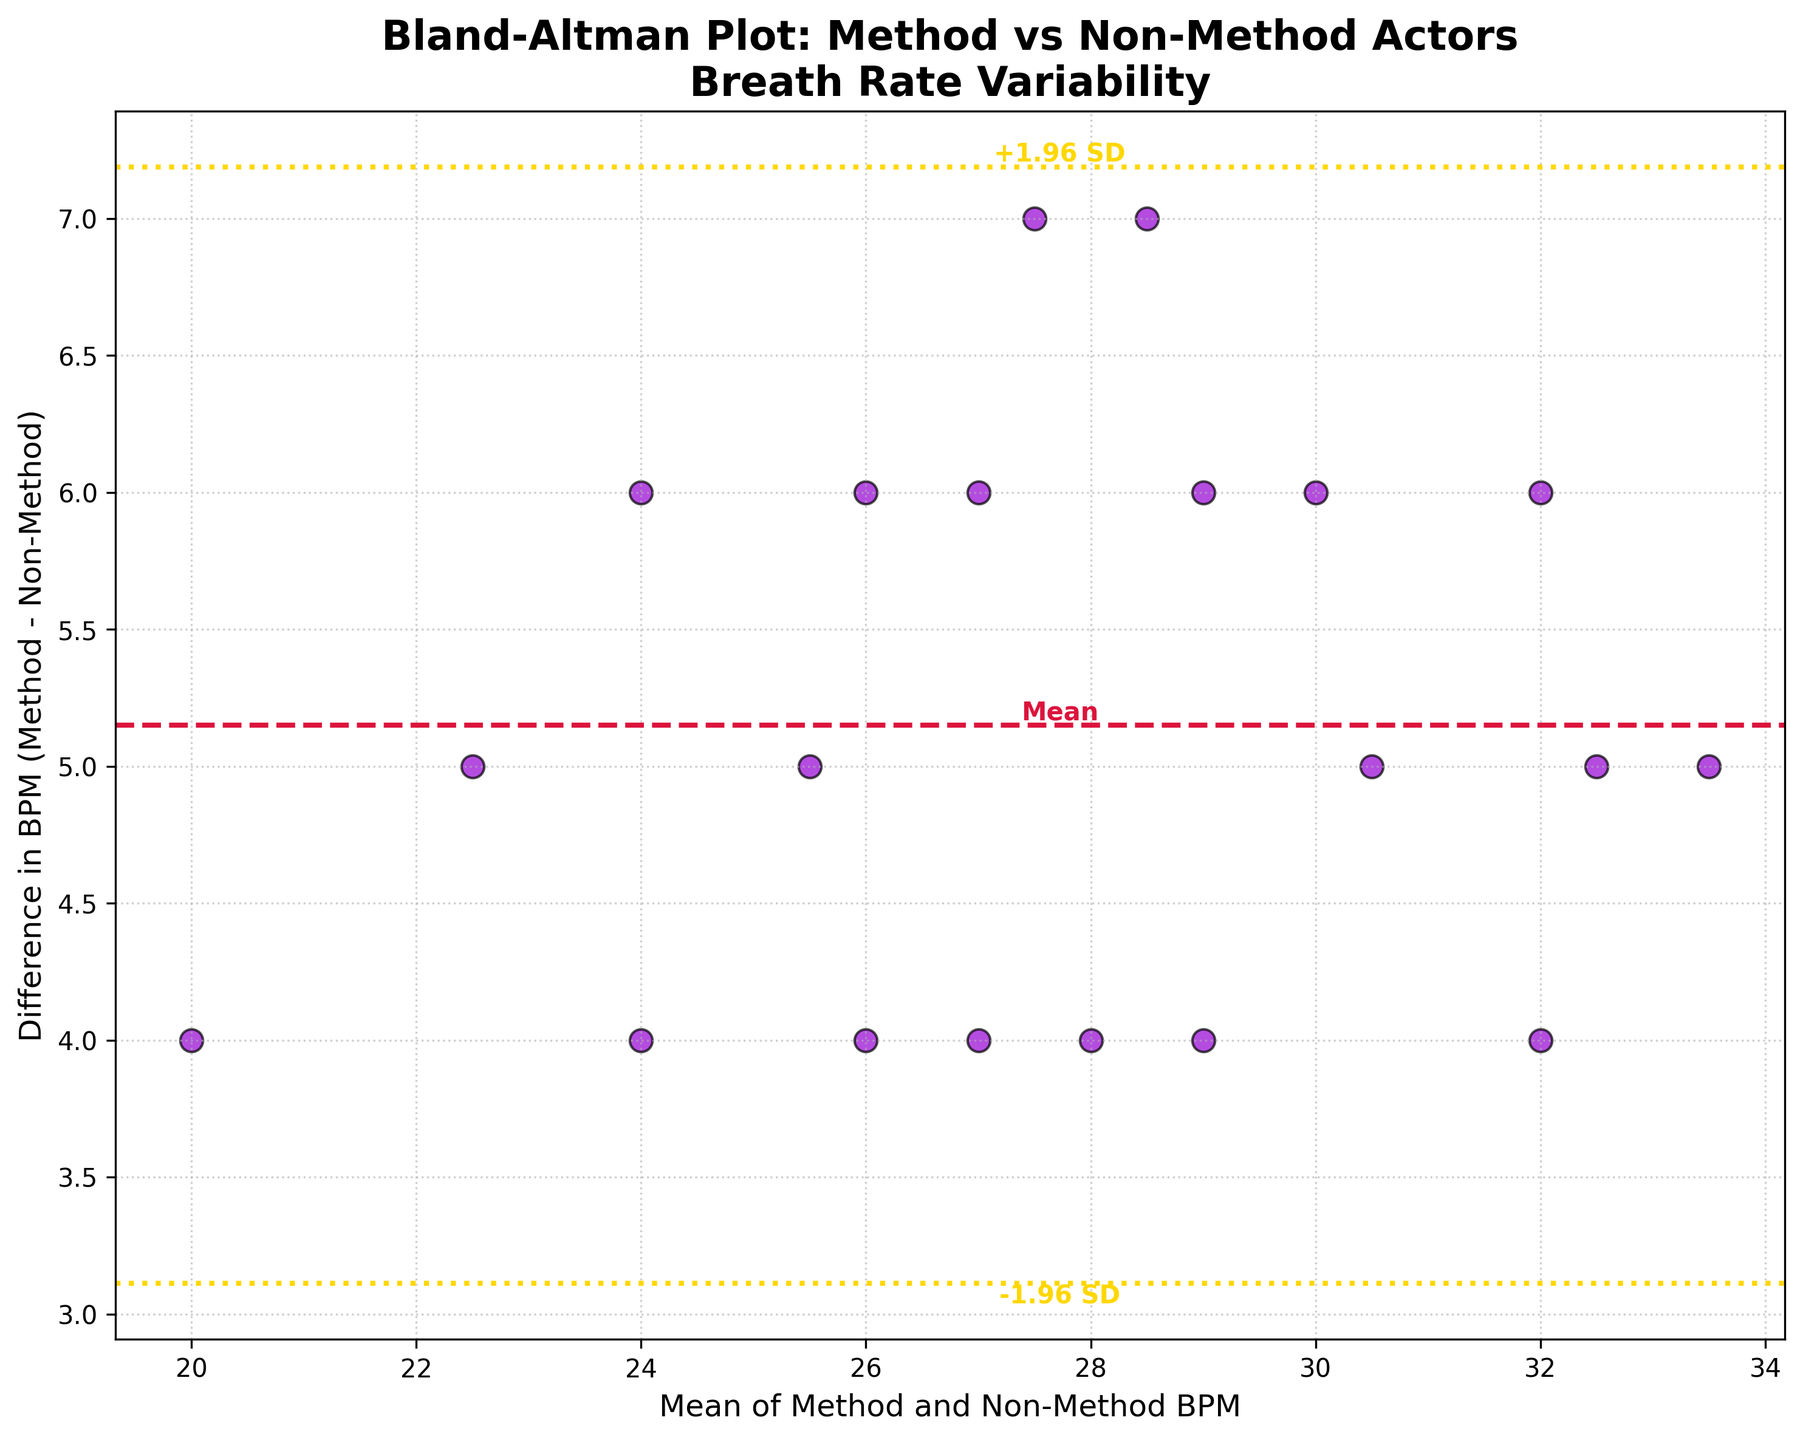What's the title of the plot? The title of the plot is shown at the top, displaying what the plot is about.
Answer: Bland-Altman Plot: Method vs Non-Method Actors Breath Rate Variability How many data points are shown in the plot? Count the number of scatter points plotted on the graph.
Answer: 20 What color are the scatter points in the plot? The scatter points' color can be identified by visually inspecting the plot.
Answer: Darkviolet What is the mean difference between the method and non-method actors' BPM? The mean difference is typically represented by a horizontal line in the plot. This plot has a dashed crimson line indicating the mean difference.
Answer: Approximately 4 BPM What value does the +1.96 standard deviation line represent? To find this value, locate the upper dashed line marked by +1.96 SD. This line usually corresponds to the mean difference plus 1.96 times the standard deviation of the differences.
Answer: Approximately 7.8 BPM Are most of the differences between method and non-method BPM positive or negative? By inspecting the scatter points relative to the zero line on the y-axis, one can see if most differences are above or below zero.
Answer: Positive What is the range of the mean BPM values in the plot? To determine this, look at the minimum and maximum values on the x-axis which represent the mean BPM values.
Answer: 20 to 34 BPM Which BPM category, method or non-method, tends to have higher values? Since most difference values (Method BPM - Non-Method BPM) are positive and above zero, the method actors' BPM tends to be higher.
Answer: Method actors How does the variability in breath rate compare between method and non-method actors? Based on the spread of the points and distance to the mean difference line, one can infer the level of variability in breath rate.
Answer: Method actors show slightly higher variability What are the boundaries for the -1.96 and +1.96 standard deviation lines? The -1.96 and +1.96 SD lines on the plot represent the mean difference plus and minus 1.96 times the standard deviation. Those lines indicate the variability boundaries of the differences.
Answer: -0.2 to 8.2 BPM 